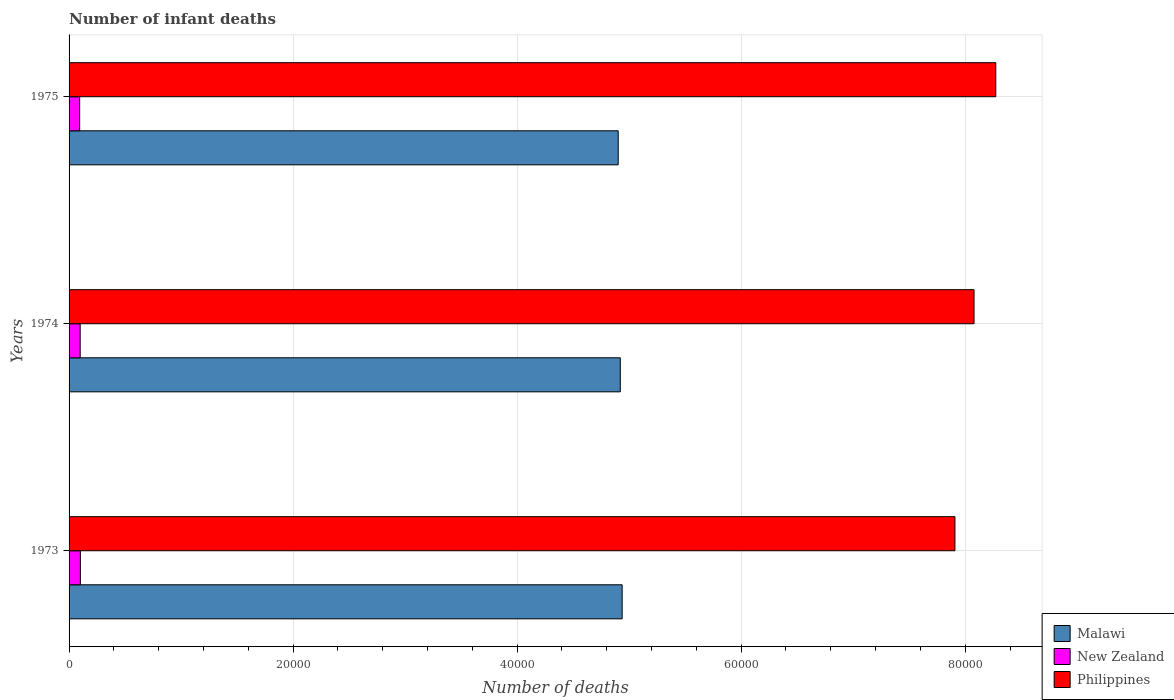Are the number of bars per tick equal to the number of legend labels?
Provide a succinct answer. Yes. Are the number of bars on each tick of the Y-axis equal?
Give a very brief answer. Yes. How many bars are there on the 1st tick from the bottom?
Your answer should be very brief. 3. What is the label of the 1st group of bars from the top?
Provide a succinct answer. 1975. What is the number of infant deaths in Malawi in 1975?
Your response must be concise. 4.90e+04. Across all years, what is the maximum number of infant deaths in Malawi?
Make the answer very short. 4.94e+04. Across all years, what is the minimum number of infant deaths in New Zealand?
Your response must be concise. 946. What is the total number of infant deaths in New Zealand in the graph?
Give a very brief answer. 2948. What is the difference between the number of infant deaths in Malawi in 1974 and that in 1975?
Your response must be concise. 185. What is the difference between the number of infant deaths in Philippines in 1975 and the number of infant deaths in New Zealand in 1974?
Your response must be concise. 8.17e+04. What is the average number of infant deaths in Malawi per year?
Keep it short and to the point. 4.92e+04. In the year 1975, what is the difference between the number of infant deaths in Malawi and number of infant deaths in Philippines?
Offer a very short reply. -3.37e+04. What is the ratio of the number of infant deaths in Malawi in 1973 to that in 1974?
Provide a short and direct response. 1. Is the difference between the number of infant deaths in Malawi in 1973 and 1975 greater than the difference between the number of infant deaths in Philippines in 1973 and 1975?
Give a very brief answer. Yes. What is the difference between the highest and the second highest number of infant deaths in Malawi?
Your answer should be very brief. 167. What is the difference between the highest and the lowest number of infant deaths in New Zealand?
Provide a short and direct response. 63. Is the sum of the number of infant deaths in Philippines in 1973 and 1974 greater than the maximum number of infant deaths in New Zealand across all years?
Provide a succinct answer. Yes. What does the 3rd bar from the top in 1975 represents?
Offer a very short reply. Malawi. Is it the case that in every year, the sum of the number of infant deaths in New Zealand and number of infant deaths in Malawi is greater than the number of infant deaths in Philippines?
Keep it short and to the point. No. How many bars are there?
Keep it short and to the point. 9. Are all the bars in the graph horizontal?
Provide a short and direct response. Yes. How many years are there in the graph?
Offer a very short reply. 3. Are the values on the major ticks of X-axis written in scientific E-notation?
Offer a very short reply. No. Does the graph contain any zero values?
Your answer should be compact. No. How many legend labels are there?
Your answer should be very brief. 3. What is the title of the graph?
Offer a very short reply. Number of infant deaths. What is the label or title of the X-axis?
Provide a succinct answer. Number of deaths. What is the label or title of the Y-axis?
Your response must be concise. Years. What is the Number of deaths of Malawi in 1973?
Your response must be concise. 4.94e+04. What is the Number of deaths of New Zealand in 1973?
Your answer should be very brief. 1009. What is the Number of deaths of Philippines in 1973?
Make the answer very short. 7.91e+04. What is the Number of deaths in Malawi in 1974?
Your answer should be very brief. 4.92e+04. What is the Number of deaths in New Zealand in 1974?
Make the answer very short. 993. What is the Number of deaths of Philippines in 1974?
Offer a very short reply. 8.08e+04. What is the Number of deaths of Malawi in 1975?
Make the answer very short. 4.90e+04. What is the Number of deaths in New Zealand in 1975?
Provide a succinct answer. 946. What is the Number of deaths of Philippines in 1975?
Keep it short and to the point. 8.27e+04. Across all years, what is the maximum Number of deaths in Malawi?
Provide a short and direct response. 4.94e+04. Across all years, what is the maximum Number of deaths in New Zealand?
Your answer should be compact. 1009. Across all years, what is the maximum Number of deaths of Philippines?
Keep it short and to the point. 8.27e+04. Across all years, what is the minimum Number of deaths in Malawi?
Provide a short and direct response. 4.90e+04. Across all years, what is the minimum Number of deaths of New Zealand?
Make the answer very short. 946. Across all years, what is the minimum Number of deaths of Philippines?
Offer a very short reply. 7.91e+04. What is the total Number of deaths of Malawi in the graph?
Give a very brief answer. 1.48e+05. What is the total Number of deaths in New Zealand in the graph?
Offer a very short reply. 2948. What is the total Number of deaths of Philippines in the graph?
Provide a short and direct response. 2.43e+05. What is the difference between the Number of deaths of Malawi in 1973 and that in 1974?
Your response must be concise. 167. What is the difference between the Number of deaths of New Zealand in 1973 and that in 1974?
Your answer should be compact. 16. What is the difference between the Number of deaths of Philippines in 1973 and that in 1974?
Keep it short and to the point. -1705. What is the difference between the Number of deaths in Malawi in 1973 and that in 1975?
Provide a short and direct response. 352. What is the difference between the Number of deaths of Philippines in 1973 and that in 1975?
Offer a very short reply. -3647. What is the difference between the Number of deaths in Malawi in 1974 and that in 1975?
Provide a short and direct response. 185. What is the difference between the Number of deaths in New Zealand in 1974 and that in 1975?
Your answer should be compact. 47. What is the difference between the Number of deaths of Philippines in 1974 and that in 1975?
Keep it short and to the point. -1942. What is the difference between the Number of deaths in Malawi in 1973 and the Number of deaths in New Zealand in 1974?
Your answer should be compact. 4.84e+04. What is the difference between the Number of deaths of Malawi in 1973 and the Number of deaths of Philippines in 1974?
Make the answer very short. -3.14e+04. What is the difference between the Number of deaths in New Zealand in 1973 and the Number of deaths in Philippines in 1974?
Give a very brief answer. -7.98e+04. What is the difference between the Number of deaths of Malawi in 1973 and the Number of deaths of New Zealand in 1975?
Your answer should be very brief. 4.84e+04. What is the difference between the Number of deaths of Malawi in 1973 and the Number of deaths of Philippines in 1975?
Keep it short and to the point. -3.34e+04. What is the difference between the Number of deaths in New Zealand in 1973 and the Number of deaths in Philippines in 1975?
Give a very brief answer. -8.17e+04. What is the difference between the Number of deaths in Malawi in 1974 and the Number of deaths in New Zealand in 1975?
Ensure brevity in your answer.  4.83e+04. What is the difference between the Number of deaths in Malawi in 1974 and the Number of deaths in Philippines in 1975?
Keep it short and to the point. -3.35e+04. What is the difference between the Number of deaths of New Zealand in 1974 and the Number of deaths of Philippines in 1975?
Your answer should be compact. -8.17e+04. What is the average Number of deaths of Malawi per year?
Your response must be concise. 4.92e+04. What is the average Number of deaths of New Zealand per year?
Your answer should be very brief. 982.67. What is the average Number of deaths of Philippines per year?
Make the answer very short. 8.09e+04. In the year 1973, what is the difference between the Number of deaths of Malawi and Number of deaths of New Zealand?
Provide a short and direct response. 4.84e+04. In the year 1973, what is the difference between the Number of deaths of Malawi and Number of deaths of Philippines?
Give a very brief answer. -2.97e+04. In the year 1973, what is the difference between the Number of deaths in New Zealand and Number of deaths in Philippines?
Provide a short and direct response. -7.81e+04. In the year 1974, what is the difference between the Number of deaths of Malawi and Number of deaths of New Zealand?
Make the answer very short. 4.82e+04. In the year 1974, what is the difference between the Number of deaths of Malawi and Number of deaths of Philippines?
Offer a terse response. -3.16e+04. In the year 1974, what is the difference between the Number of deaths of New Zealand and Number of deaths of Philippines?
Give a very brief answer. -7.98e+04. In the year 1975, what is the difference between the Number of deaths in Malawi and Number of deaths in New Zealand?
Ensure brevity in your answer.  4.81e+04. In the year 1975, what is the difference between the Number of deaths in Malawi and Number of deaths in Philippines?
Keep it short and to the point. -3.37e+04. In the year 1975, what is the difference between the Number of deaths in New Zealand and Number of deaths in Philippines?
Provide a short and direct response. -8.18e+04. What is the ratio of the Number of deaths of New Zealand in 1973 to that in 1974?
Your response must be concise. 1.02. What is the ratio of the Number of deaths in Philippines in 1973 to that in 1974?
Offer a terse response. 0.98. What is the ratio of the Number of deaths in New Zealand in 1973 to that in 1975?
Provide a succinct answer. 1.07. What is the ratio of the Number of deaths of Philippines in 1973 to that in 1975?
Ensure brevity in your answer.  0.96. What is the ratio of the Number of deaths of Malawi in 1974 to that in 1975?
Ensure brevity in your answer.  1. What is the ratio of the Number of deaths in New Zealand in 1974 to that in 1975?
Provide a succinct answer. 1.05. What is the ratio of the Number of deaths of Philippines in 1974 to that in 1975?
Your answer should be very brief. 0.98. What is the difference between the highest and the second highest Number of deaths of Malawi?
Make the answer very short. 167. What is the difference between the highest and the second highest Number of deaths in Philippines?
Offer a terse response. 1942. What is the difference between the highest and the lowest Number of deaths of Malawi?
Your answer should be very brief. 352. What is the difference between the highest and the lowest Number of deaths in New Zealand?
Your response must be concise. 63. What is the difference between the highest and the lowest Number of deaths of Philippines?
Keep it short and to the point. 3647. 